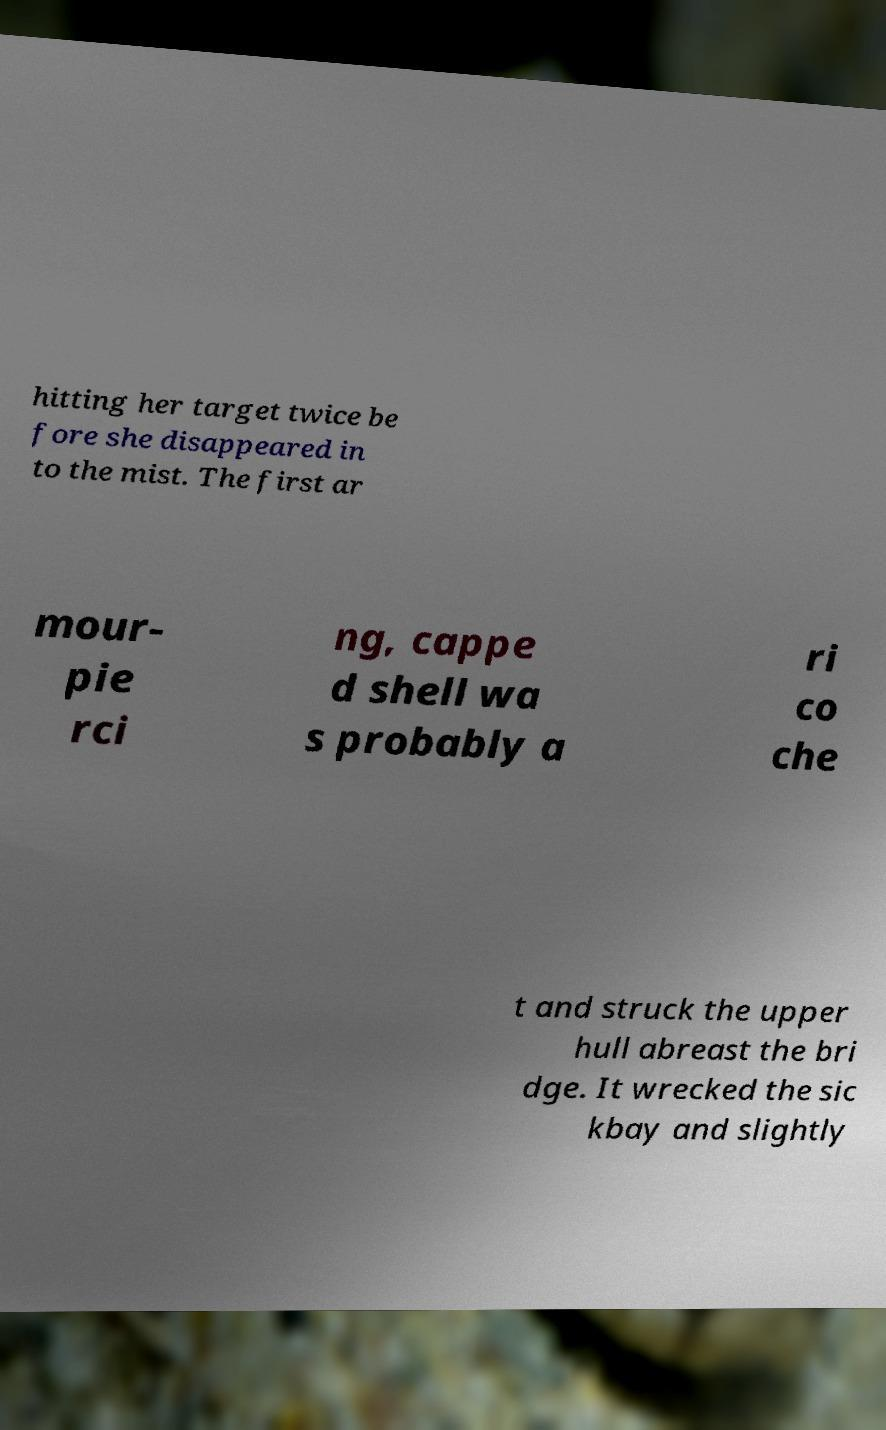Please identify and transcribe the text found in this image. hitting her target twice be fore she disappeared in to the mist. The first ar mour- pie rci ng, cappe d shell wa s probably a ri co che t and struck the upper hull abreast the bri dge. It wrecked the sic kbay and slightly 